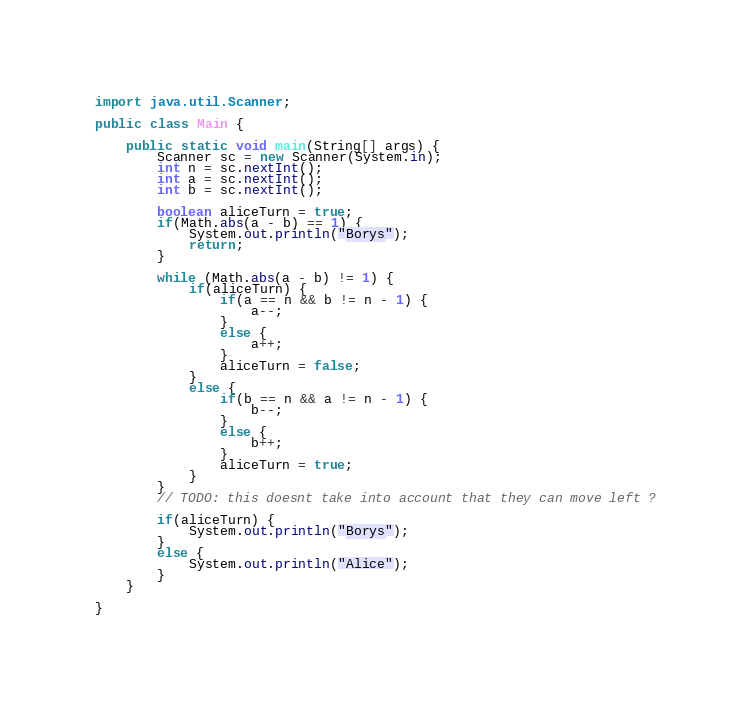Convert code to text. <code><loc_0><loc_0><loc_500><loc_500><_Java_>
import java.util.Scanner;

public class Main {

    public static void main(String[] args) {
        Scanner sc = new Scanner(System.in);
        int n = sc.nextInt();
        int a = sc.nextInt();
        int b = sc.nextInt();

        boolean aliceTurn = true;
        if(Math.abs(a - b) == 1) {
            System.out.println("Borys");
            return;
        }

        while (Math.abs(a - b) != 1) {
            if(aliceTurn) {
                if(a == n && b != n - 1) {
                    a--;
                }
                else {
                    a++;
                }
                aliceTurn = false;
            }
            else {
                if(b == n && a != n - 1) {
                    b--;
                }
                else {
                    b++;
                }
                aliceTurn = true;
            }
        }
        // TODO: this doesnt take into account that they can move left ?

        if(aliceTurn) {
            System.out.println("Borys");
        }
        else {
            System.out.println("Alice");
        }
    }

}
</code> 